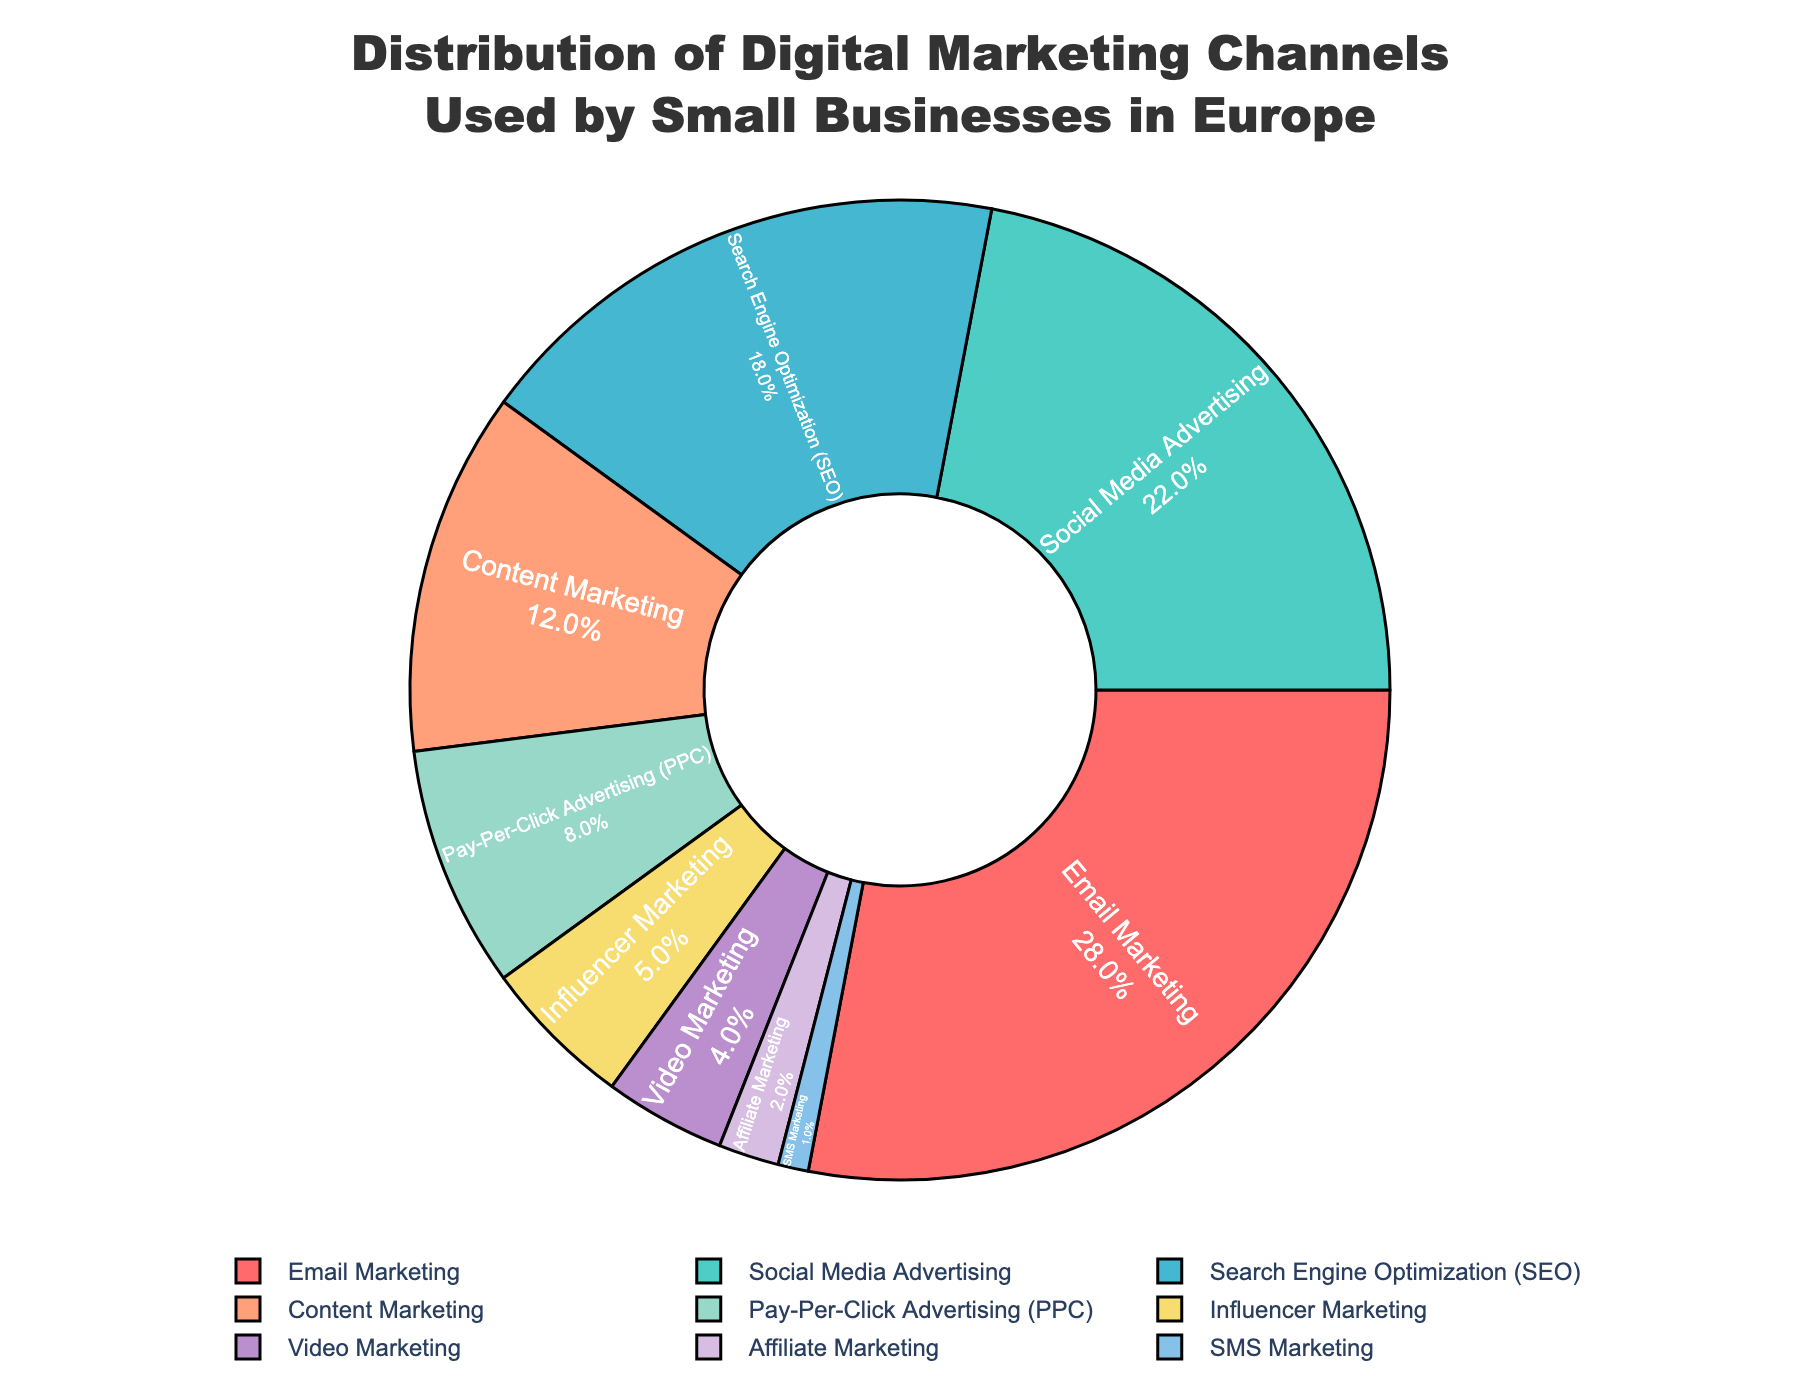Which digital marketing channel has the highest usage percentage among small businesses in Europe? The largest slice of the pie chart represents the channel with the highest percentage. Looking at the chart, Email Marketing takes up the largest portion at 28%.
Answer: Email Marketing What is the percentage difference between Social Media Advertising and Influencer Marketing? Social Media Advertising has a percentage of 22% and Influencer Marketing has 5%. Subtract 5 from 22 to find the difference.
Answer: 17% How many channels have a percentage usage greater than 10%? To find the number of channels with percentages greater than 10%, look at each slice's percentage in the chart. Email Marketing, Social Media Advertising, Search Engine Optimization (SEO), and Content Marketing each have a percentage greater than 10%. Thus, there are 4 channels.
Answer: 4 Which channel is utilized more: Pay-Per-Click Advertising (PPC) or Video Marketing? Compare the percentages of the two channels. PPC has 8%, and Video Marketing has 4%. Since 8% is greater than 4%, PPC is utilized more.
Answer: Pay-Per-Click Advertising (PPC) What is the total percentage of SEO, Content Marketing, and Influencer Marketing combined? Add the percentages of Search Engine Optimization (SEO), Content Marketing, and Influencer Marketing: 18% + 12% + 5% = 35%.
Answer: 35% Compare the combined usage percentage of Email Marketing and Social Media Advertising with the combined percentage of Video Marketing and Affiliate Marketing. Which is greater, and by how much? The combined percentage for Email Marketing and Social Media Advertising is 28% + 22% = 50%. The combined percentage for Video Marketing and Affiliate Marketing is 4% + 2% = 6%. Subtract 6% from 50% to find the difference.
Answer: Email Marketing and Social Media Advertising by 44% What percentage of small businesses use SMS Marketing? The slice for SMS Marketing shows a label with the corresponding percentage, which is 1%.
Answer: 1% How does the usage of Content Marketing compare visually to that of PPC? Visually, the slice for Content Marketing is larger than the slice for PPC, indicating a higher usage percentage for Content Marketing (12%) compared to PPC (8%).
Answer: Content Marketing is larger 